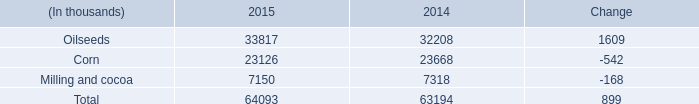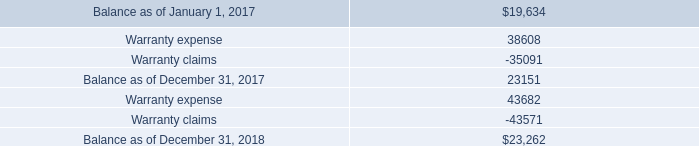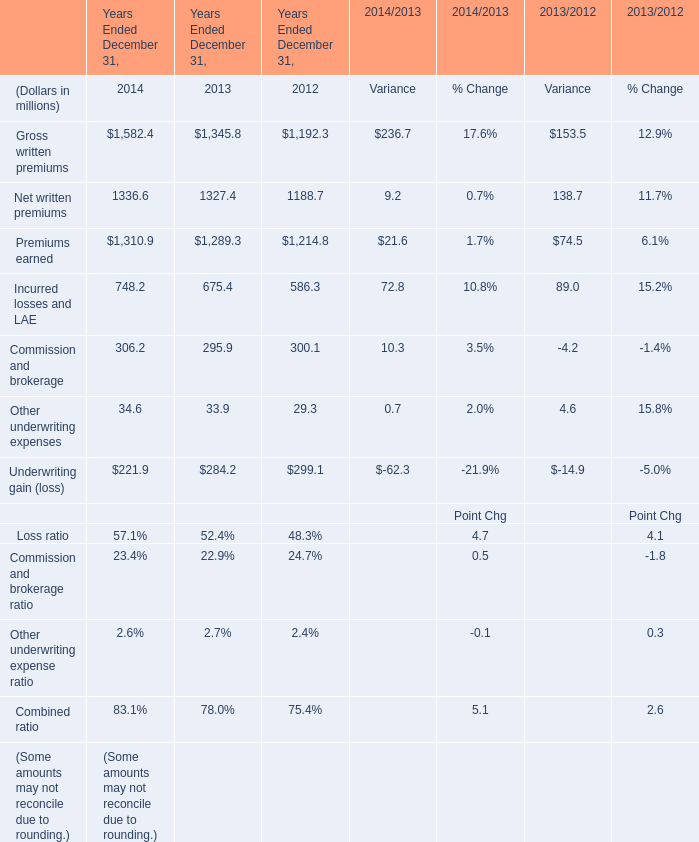In the year with largest amount of Commission and brokerage, what's the increasing rate of Other underwriting expenses? 
Computations: ((34.6 - 33.9) / 33.9)
Answer: 0.02065. 